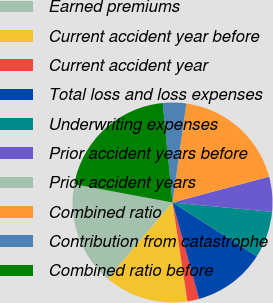<chart> <loc_0><loc_0><loc_500><loc_500><pie_chart><fcel>Earned premiums<fcel>Current accident year before<fcel>Current accident year<fcel>Total loss and loss expenses<fcel>Underwriting expenses<fcel>Prior accident years before<fcel>Prior accident years<fcel>Combined ratio<fcel>Contribution from catastrophe<fcel>Combined ratio before<nl><fcel>16.74%<fcel>13.58%<fcel>1.9%<fcel>11.7%<fcel>7.53%<fcel>5.65%<fcel>0.02%<fcel>18.62%<fcel>3.77%<fcel>20.5%<nl></chart> 